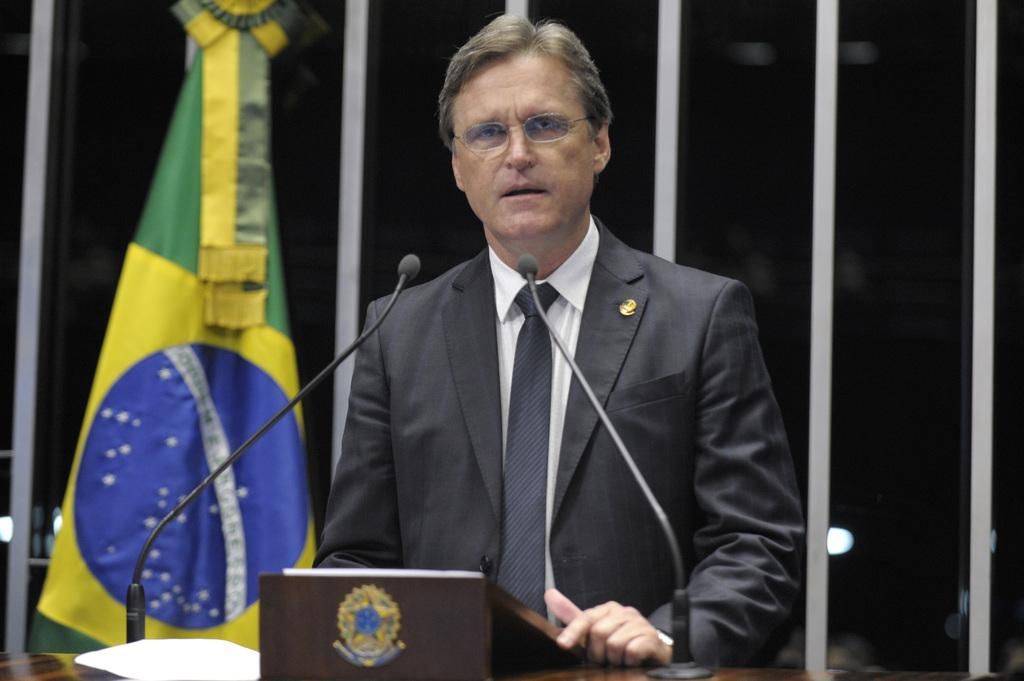What is the main object on the podium in the image? Papers are present on the podium. What other items can be seen on the podium? There are microphones on the podium. Who is standing behind the podium? A man is standing behind the podium. Can you see any other people in the image? Yes, there is a man standing in the background. What is visible in the background of the image? There is a flag in the background. What type of flowers are on the podium in the image? There are no flowers present on the podium in the image. What time is displayed on the clock in the image? There is no clock present in the image. 